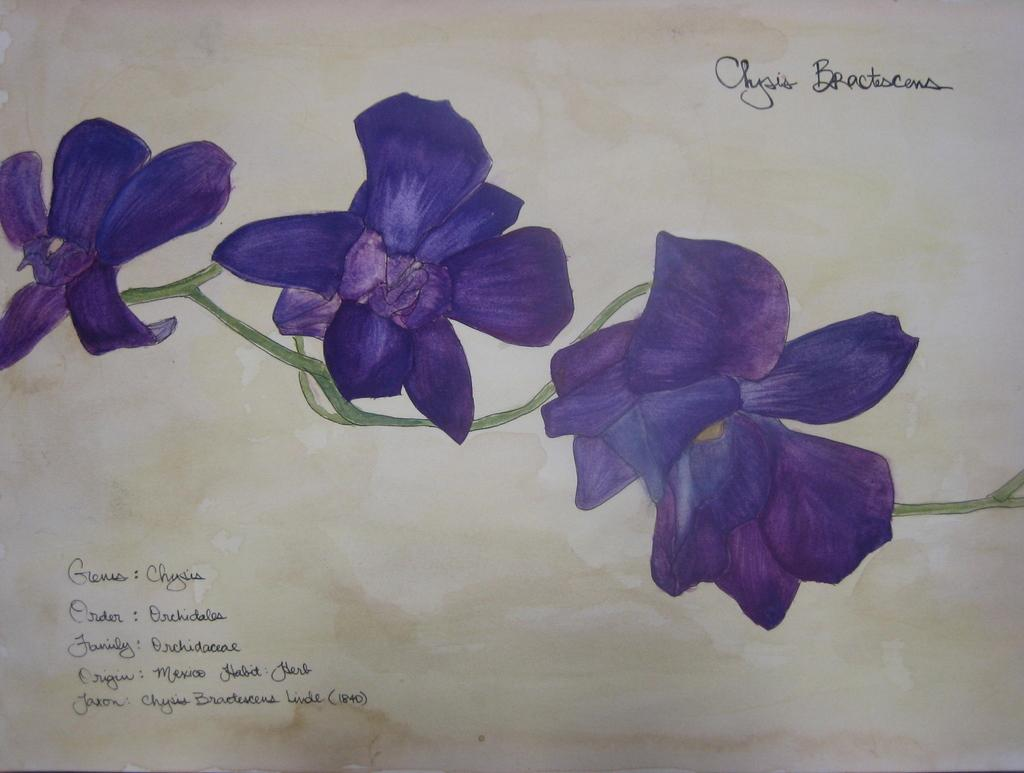What is the focus of the image? The image is a zoomed in picture. What can be seen in the zoomed in picture? There is a painting of flowers in the image. Are there any words or phrases in the image? Yes, text is written on the image. What type of hose is being used to water the flowers in the image? There is no hose present in the image; it is a painting of flowers. How many pickles are visible in the image? There are no pickles present in the image; it is a painting of flowers. 